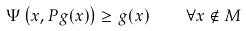Convert formula to latex. <formula><loc_0><loc_0><loc_500><loc_500>\Psi \left ( x , P g ( x ) \right ) \geq g ( x ) \quad \forall x \notin M</formula> 